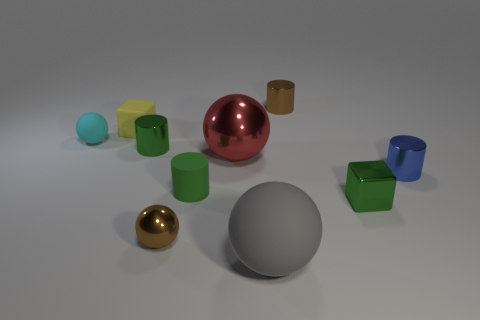Is there any other thing of the same color as the small metal sphere?
Keep it short and to the point. Yes. Are there any gray objects that are left of the tiny green shiny object in front of the big metallic sphere that is behind the tiny rubber cylinder?
Offer a very short reply. Yes. Is the color of the small metallic cylinder that is to the left of the brown cylinder the same as the cube that is on the right side of the green rubber cylinder?
Offer a very short reply. Yes. What is the material of the cyan thing that is the same size as the yellow matte cube?
Make the answer very short. Rubber. There is a metal cylinder on the left side of the tiny rubber object in front of the sphere behind the large metal object; what is its size?
Offer a very short reply. Small. What number of other objects are there of the same material as the brown sphere?
Your answer should be compact. 5. What size is the metal cylinder left of the brown sphere?
Keep it short and to the point. Small. How many cylinders are in front of the red ball and to the left of the red shiny ball?
Your response must be concise. 1. There is a tiny cylinder behind the small matte thing that is behind the tiny matte sphere; what is it made of?
Provide a succinct answer. Metal. What is the material of the other big object that is the same shape as the big matte thing?
Your answer should be compact. Metal. 